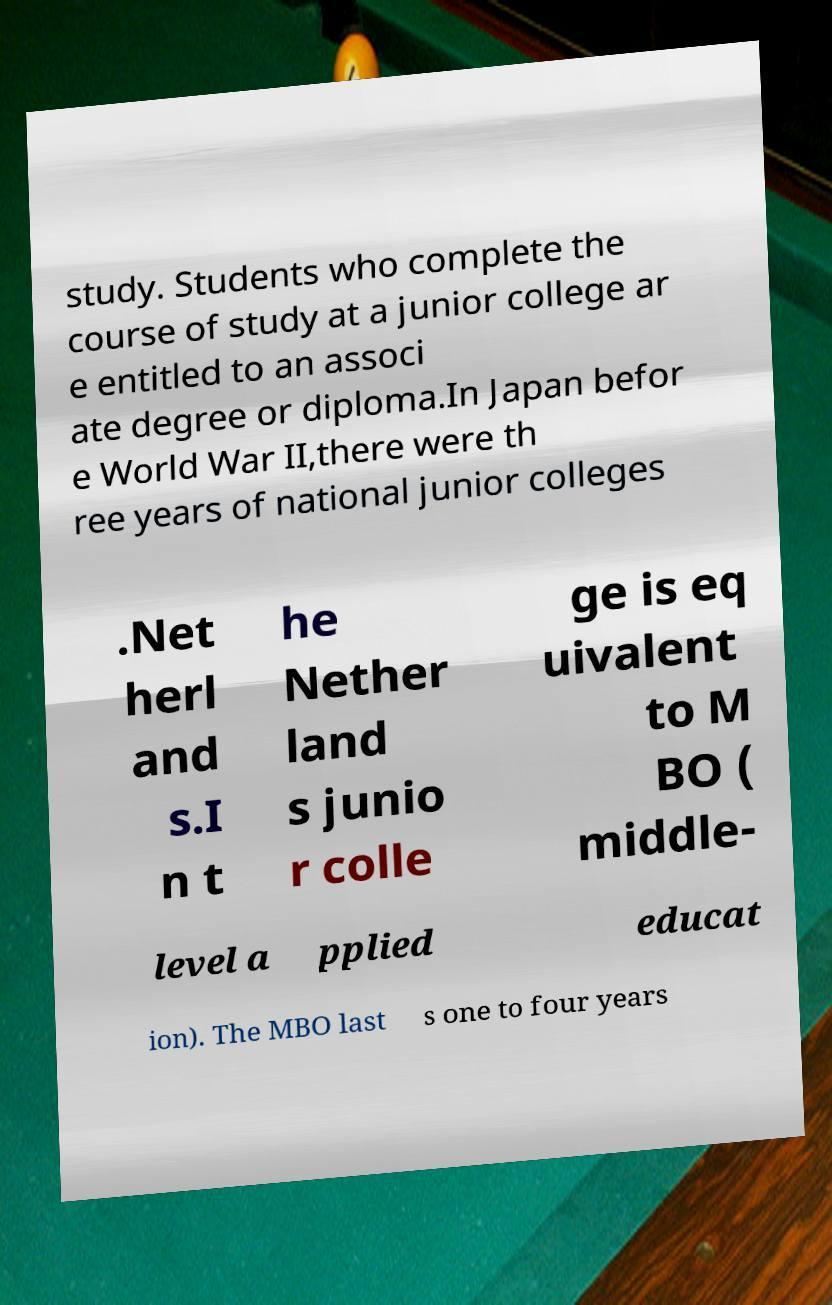Please read and relay the text visible in this image. What does it say? study. Students who complete the course of study at a junior college ar e entitled to an associ ate degree or diploma.In Japan befor e World War II,there were th ree years of national junior colleges .Net herl and s.I n t he Nether land s junio r colle ge is eq uivalent to M BO ( middle- level a pplied educat ion). The MBO last s one to four years 